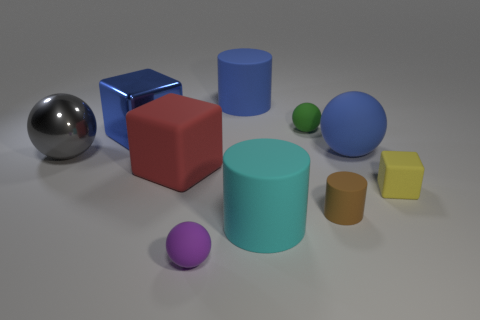There is a small object that is both in front of the yellow rubber object and behind the big cyan matte cylinder; what material is it?
Give a very brief answer. Rubber. There is a green object; is its size the same as the blue rubber object that is on the left side of the tiny brown rubber cylinder?
Make the answer very short. No. What number of other things are the same color as the small rubber block?
Provide a succinct answer. 0. Is the number of big cubes that are behind the blue matte ball greater than the number of small metal things?
Keep it short and to the point. Yes. There is a large ball right of the small thing that is behind the blue rubber thing that is in front of the tiny green object; what is its color?
Offer a terse response. Blue. Does the large gray sphere have the same material as the blue cube?
Keep it short and to the point. Yes. Are there any blue rubber spheres of the same size as the gray sphere?
Make the answer very short. Yes. There is a purple sphere that is the same size as the green rubber ball; what material is it?
Give a very brief answer. Rubber. Is there a tiny thing that has the same shape as the large red rubber thing?
Keep it short and to the point. Yes. There is a cube that is the same color as the large rubber sphere; what material is it?
Provide a succinct answer. Metal. 